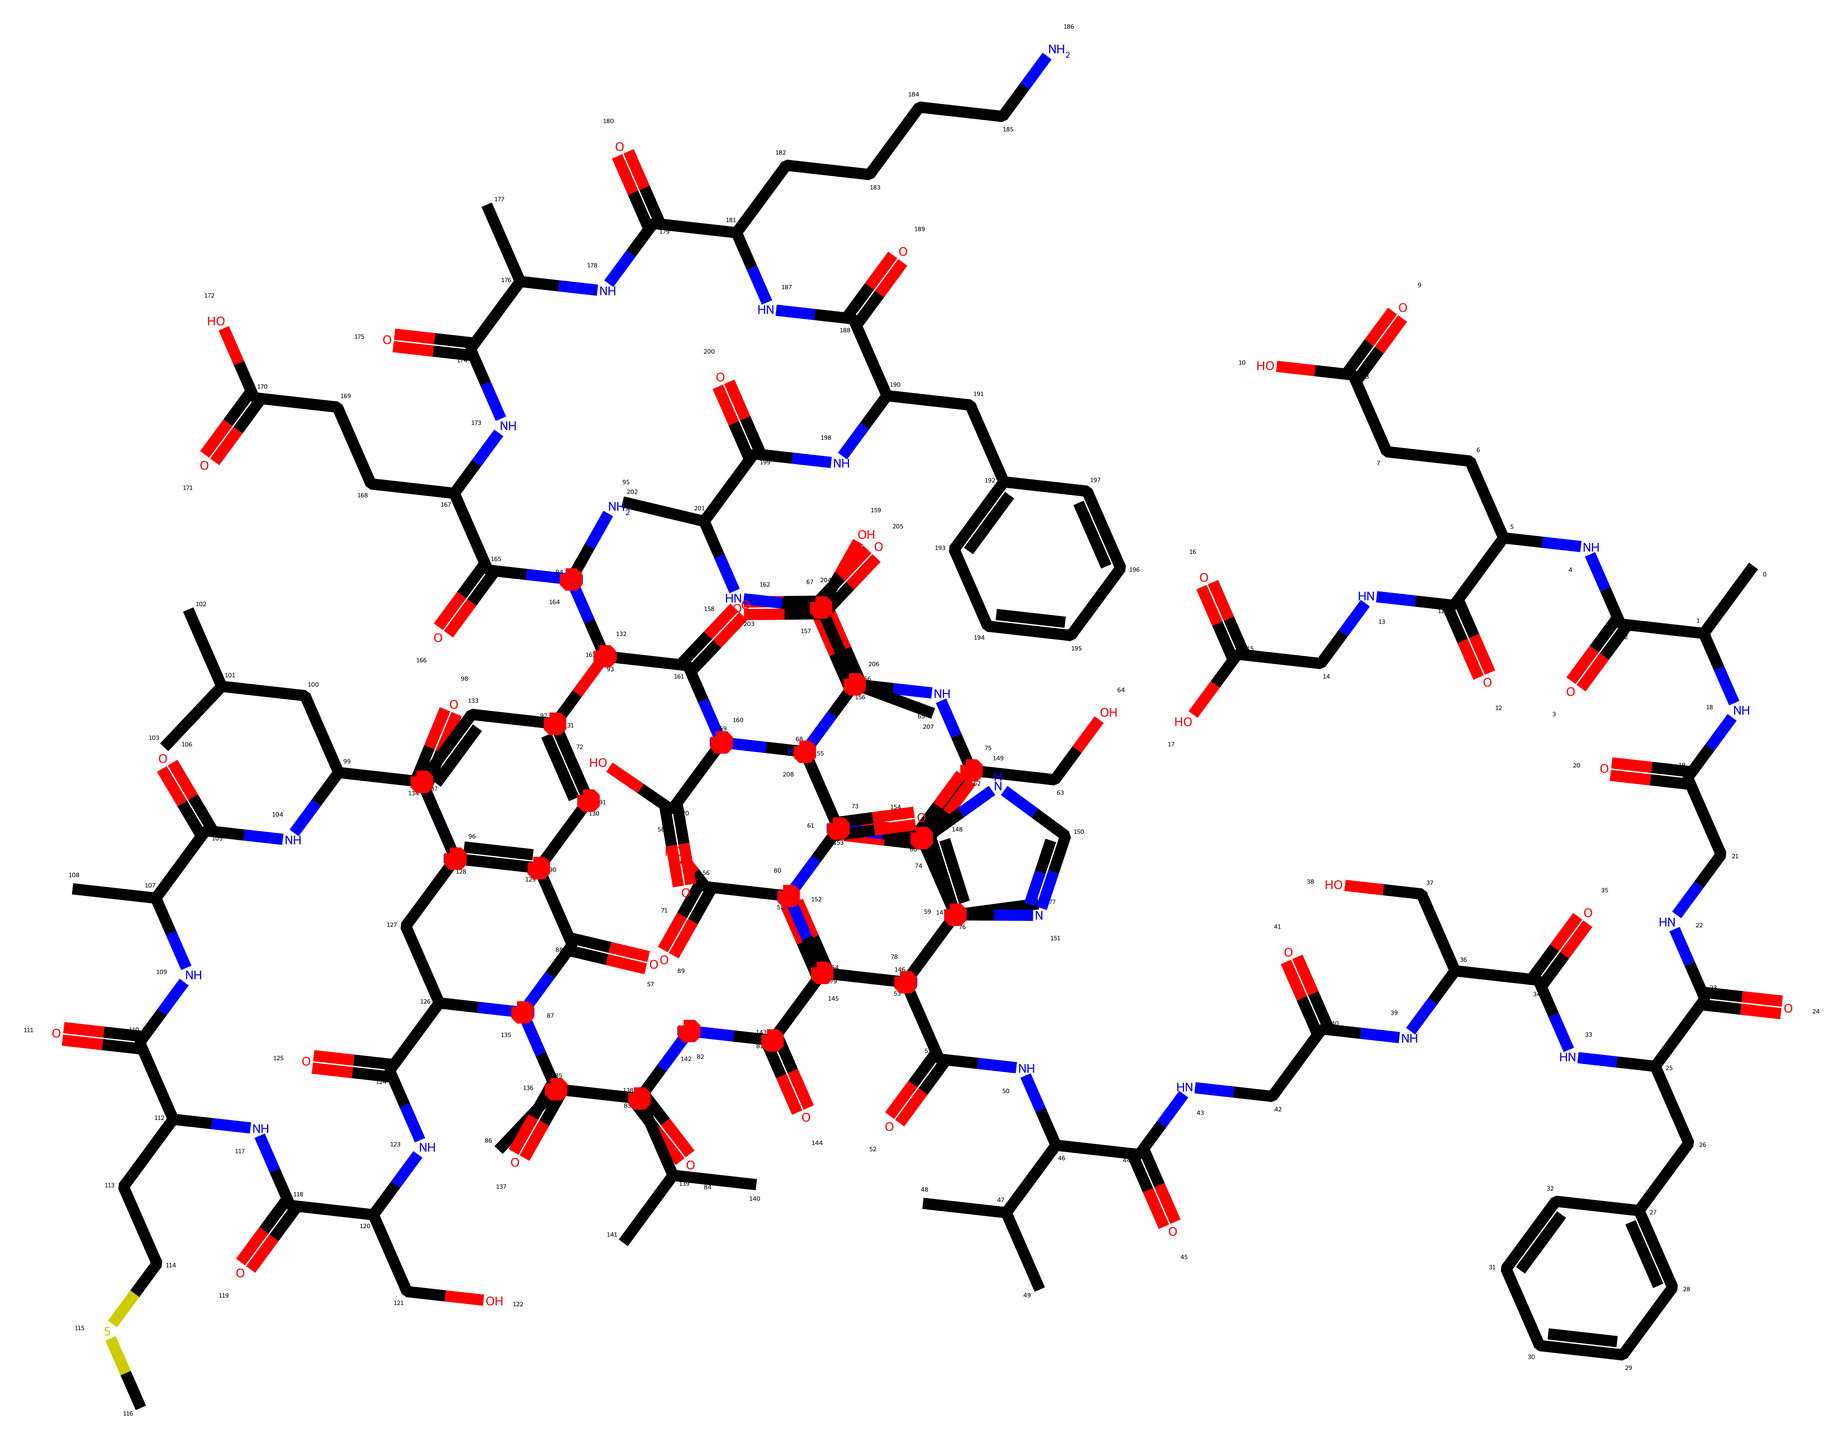What is the primary purpose of gelatin in food? Gelatin primarily acts as a gelling agent in food products, which helps to create the desired texture for dishes like Jell-O.
Answer: gelling agent How many carbon atoms are present in the structure? By analyzing the SMILES representation, I counted the number of carbon (C) atoms present in the structure, which totals 42 carbon atoms.
Answer: 42 What type of chemical bond connects the amino acids in gelatin? The amino acids in gelatin are connected primarily by peptide bonds, which are covalent bonds formed between the amino group of one amino acid and the carboxyl group of another.
Answer: peptide bonds How many rings are present in the structure of this chemical? The structure contains several aromatic rings, specifically noting that there are four distinct cyclic structures evident from the rings in the SMILES representation.
Answer: 4 Which functional groups are found in gelatin based on its structure? The structure reveals multiple functional groups such as amine (NH2), carboxylic acid (COOH), and amide (CONH), which are characteristic of proteins like gelatin.
Answer: amine, carboxylic acid, amide What is the solubility property of gelatin in water? Gelatin is generally soluble in warm water, due to its hydrophilic functional groups which interact with water molecules, allowing it to dissolve and form a gel.
Answer: soluble How does the structure of gelatin affect its thermal properties? The presence of hydrogen bonds formed between the gelatin molecules contributes to its thermal properties, particularly its ability to gel upon cooling and melt when heated.
Answer: hydrogen bonds 